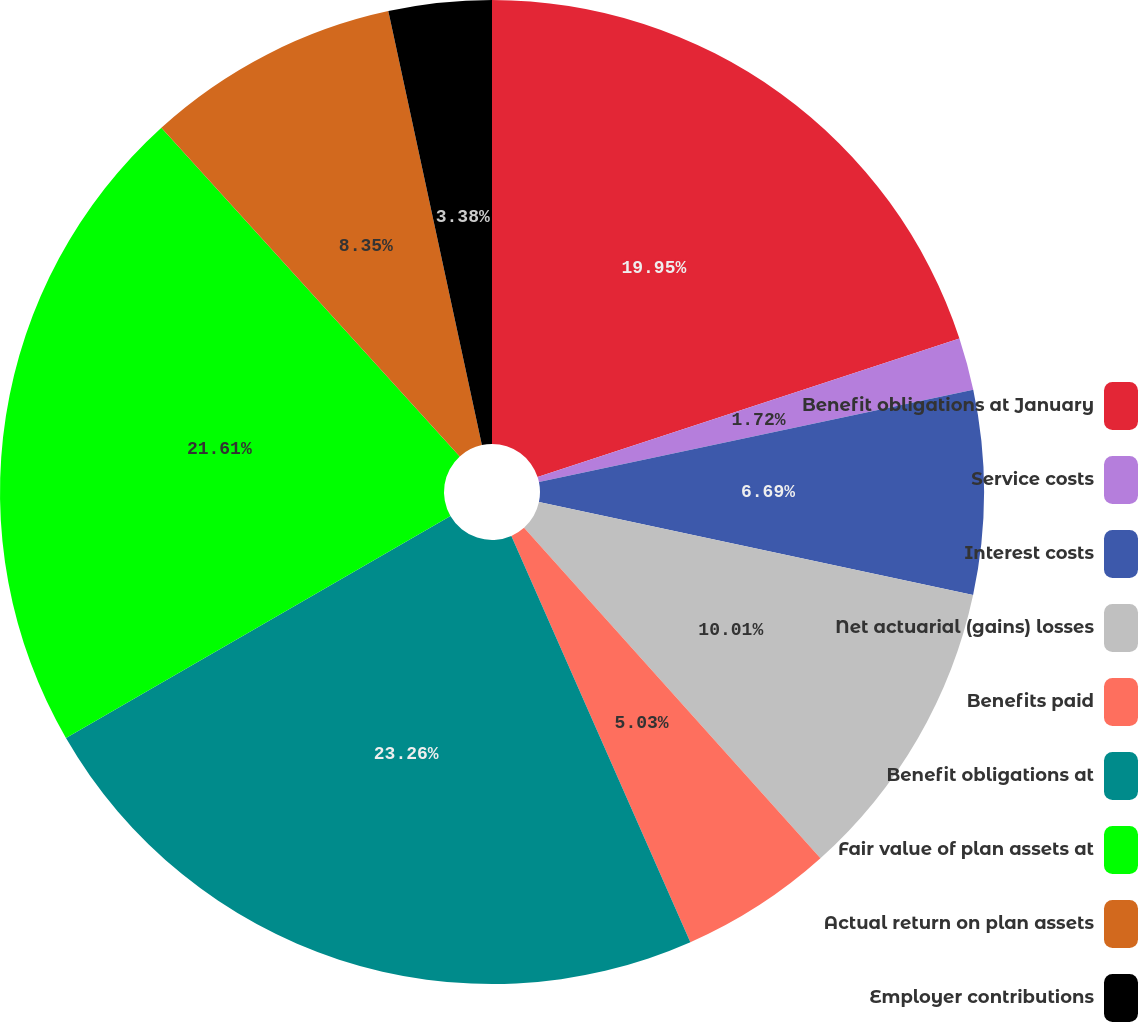Convert chart. <chart><loc_0><loc_0><loc_500><loc_500><pie_chart><fcel>Benefit obligations at January<fcel>Service costs<fcel>Interest costs<fcel>Net actuarial (gains) losses<fcel>Benefits paid<fcel>Benefit obligations at<fcel>Fair value of plan assets at<fcel>Actual return on plan assets<fcel>Employer contributions<nl><fcel>19.95%<fcel>1.72%<fcel>6.69%<fcel>10.01%<fcel>5.03%<fcel>23.27%<fcel>21.61%<fcel>8.35%<fcel>3.38%<nl></chart> 